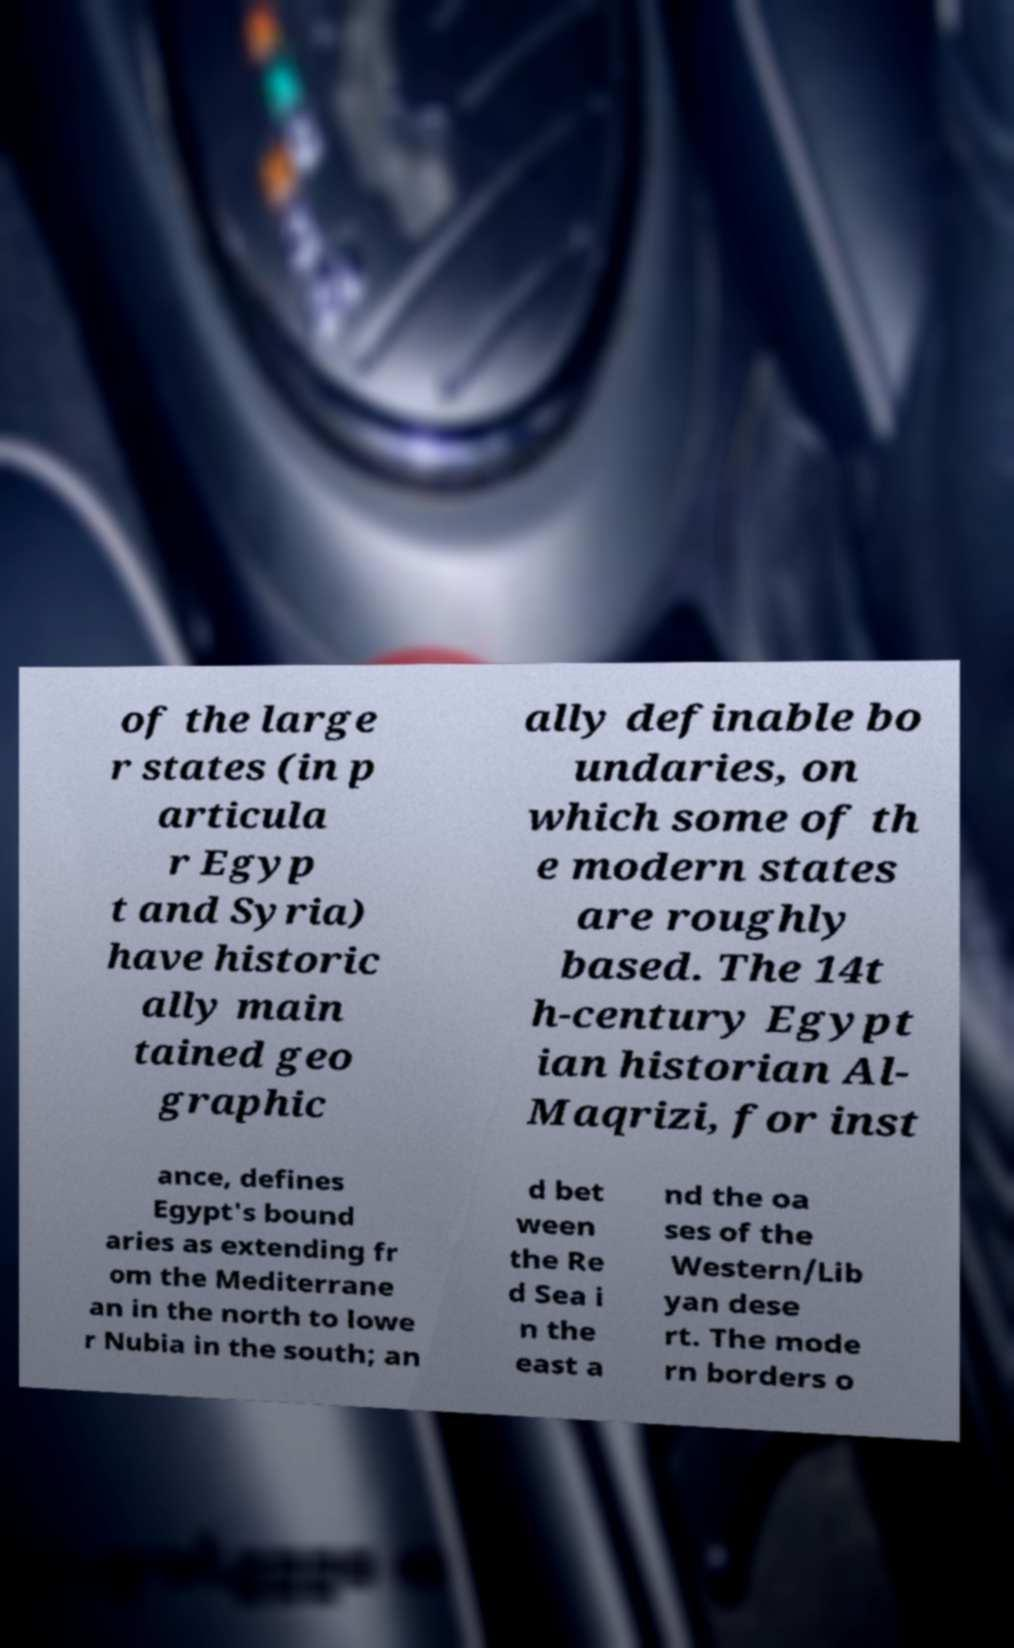Could you extract and type out the text from this image? of the large r states (in p articula r Egyp t and Syria) have historic ally main tained geo graphic ally definable bo undaries, on which some of th e modern states are roughly based. The 14t h-century Egypt ian historian Al- Maqrizi, for inst ance, defines Egypt's bound aries as extending fr om the Mediterrane an in the north to lowe r Nubia in the south; an d bet ween the Re d Sea i n the east a nd the oa ses of the Western/Lib yan dese rt. The mode rn borders o 